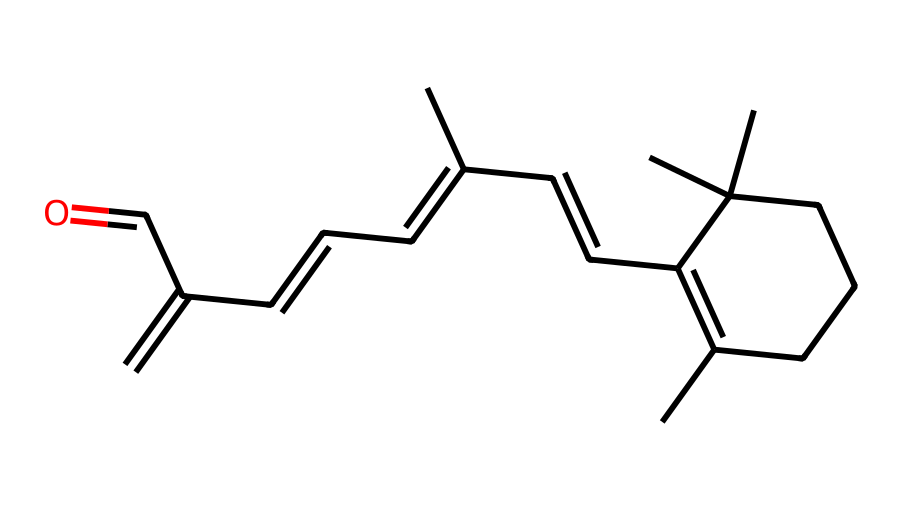What is the IUPAC name of this chemical? The SMILES representation corresponds to the structure of retinol, which is known as vitamin A1. The IUPAC name can be derived from recognizing the key functional groups and structure features present.
Answer: retinol How many double bonds are present in the molecular structure? By analyzing the structure represented in the SMILES, I can count the double bonds, which are indicated by "C=C" connections. In this case, there are five occurrences of double bonds.
Answer: five What type of functional group is present at the end of this molecule? The structure reveals an aldehyde group at one end, characterized by the presence of a carbon atom double-bonded to an oxygen atom and single-bonded to a hydrogen atom. This is typically noted in the final part of the SMILES representation.
Answer: aldehyde How many carbon atoms are in the molecule? Counting the carbon atoms in the SMILES string reveals that there are 20 carbon atoms present in this molecule. This count includes all the branching and chain carbons.
Answer: twenty Is this compound saturated or unsaturated? The presence of multiple double bonds within the structure indicates that it is unsaturated, as saturation refers to the absence of double or triple bonds between carbon atoms.
Answer: unsaturated 